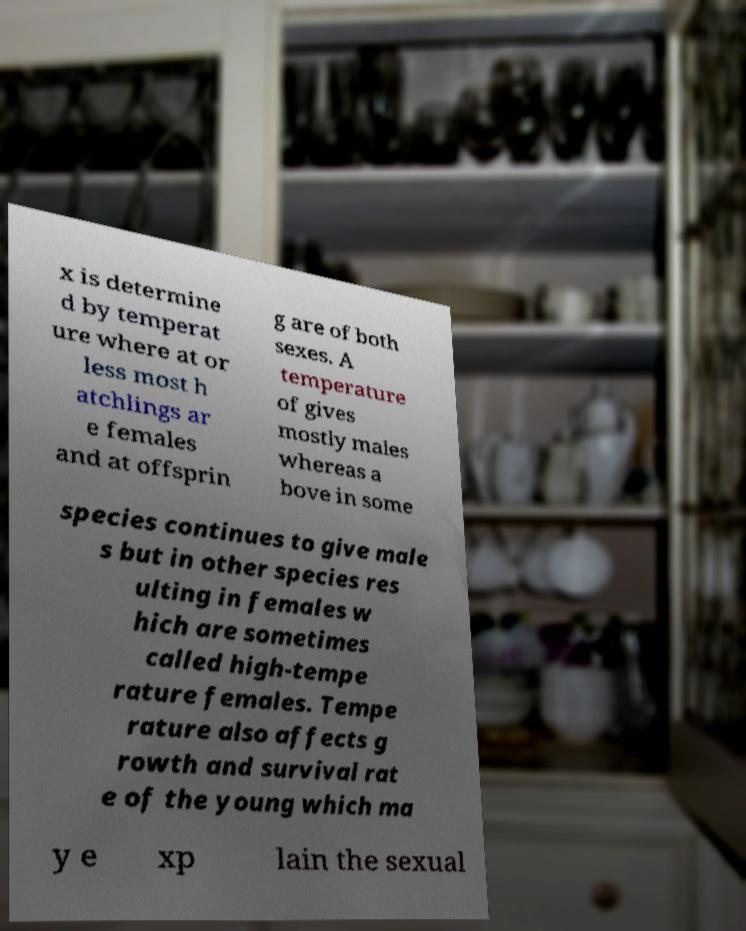I need the written content from this picture converted into text. Can you do that? x is determine d by temperat ure where at or less most h atchlings ar e females and at offsprin g are of both sexes. A temperature of gives mostly males whereas a bove in some species continues to give male s but in other species res ulting in females w hich are sometimes called high-tempe rature females. Tempe rature also affects g rowth and survival rat e of the young which ma y e xp lain the sexual 